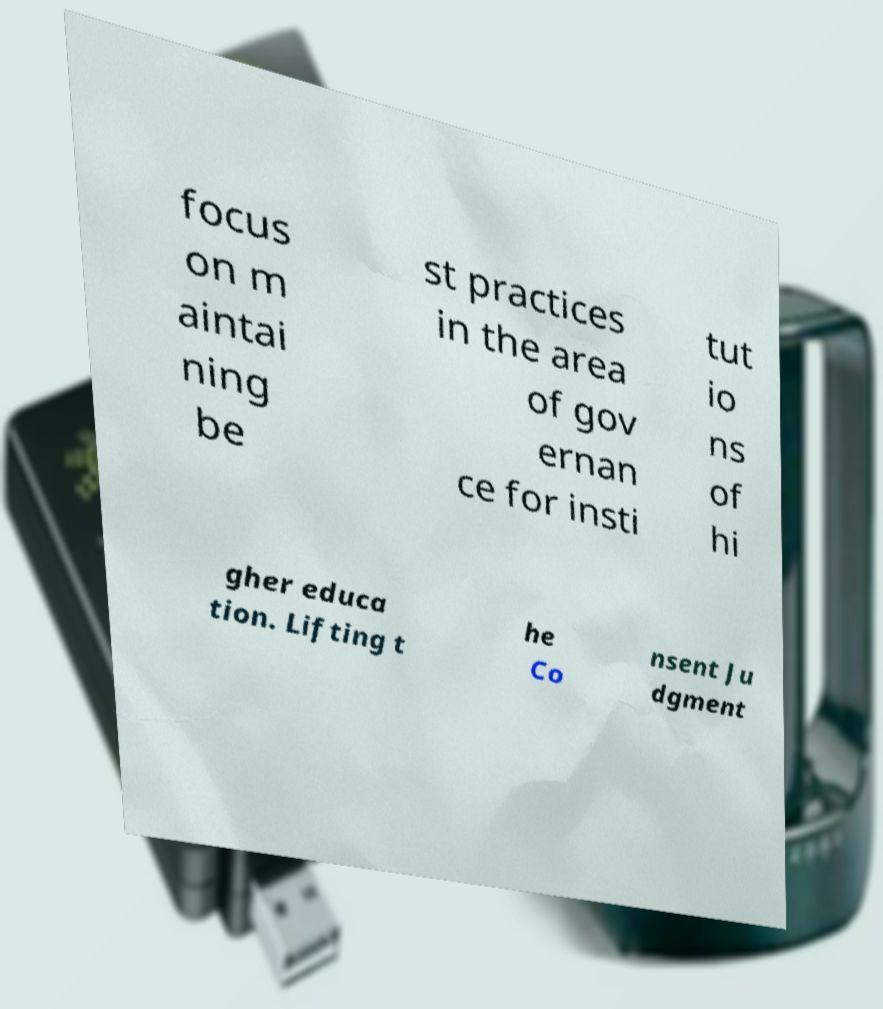Could you extract and type out the text from this image? focus on m aintai ning be st practices in the area of gov ernan ce for insti tut io ns of hi gher educa tion. Lifting t he Co nsent Ju dgment 